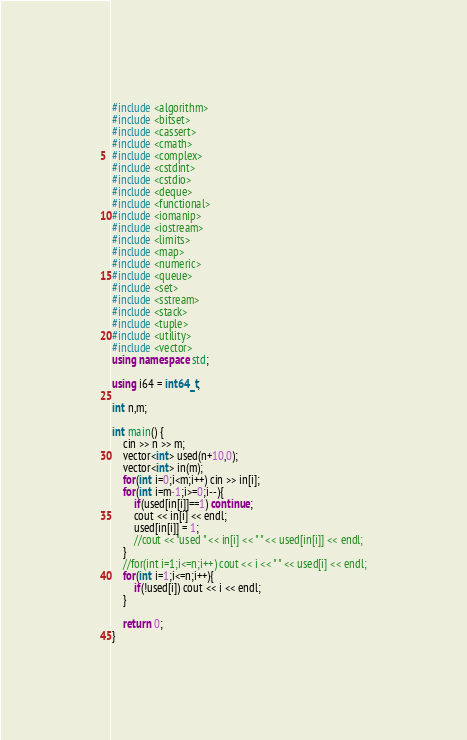Convert code to text. <code><loc_0><loc_0><loc_500><loc_500><_C++_>#include <algorithm>
#include <bitset>
#include <cassert>
#include <cmath>
#include <complex>
#include <cstdint>
#include <cstdio>
#include <deque>
#include <functional>
#include <iomanip>
#include <iostream>
#include <limits>
#include <map>
#include <numeric>
#include <queue>
#include <set>
#include <sstream>
#include <stack>
#include <tuple>
#include <utility>
#include <vector>
using namespace std;

using i64 = int64_t;

int n,m;

int main() {
    cin >> n >> m;
    vector<int> used(n+10,0);
    vector<int> in(m);
    for(int i=0;i<m;i++) cin >> in[i];
    for(int i=m-1;i>=0;i--){
        if(used[in[i]]==1) continue;
        cout << in[i] << endl;
        used[in[i]] = 1;
        //cout << "used " << in[i] << " " << used[in[i]] << endl;
    }
    //for(int i=1;i<=n;i++) cout << i << " " << used[i] << endl;
    for(int i=1;i<=n;i++){
        if(!used[i]) cout << i << endl;
    }

    return 0;
}</code> 